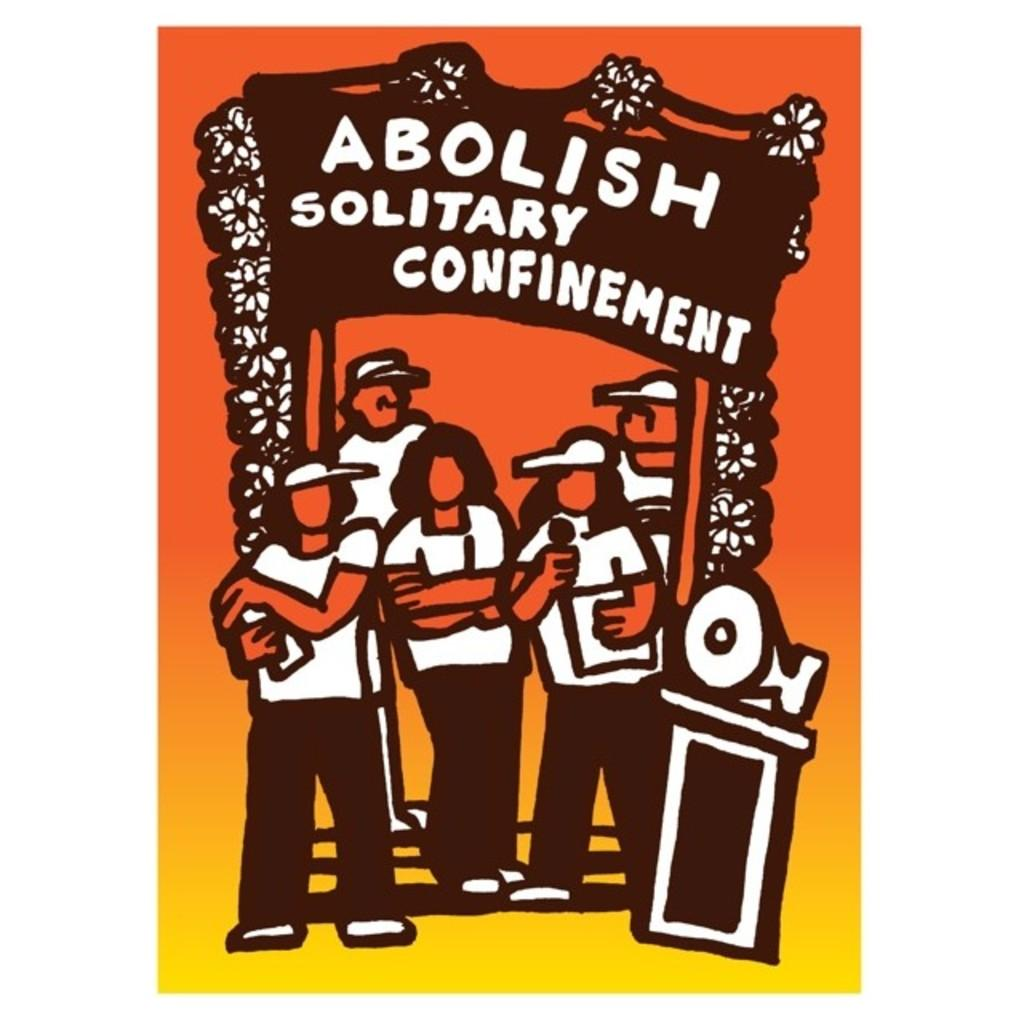<image>
Create a compact narrative representing the image presented. The cartoon poster shown is asking that solitary confinement is abolished. 